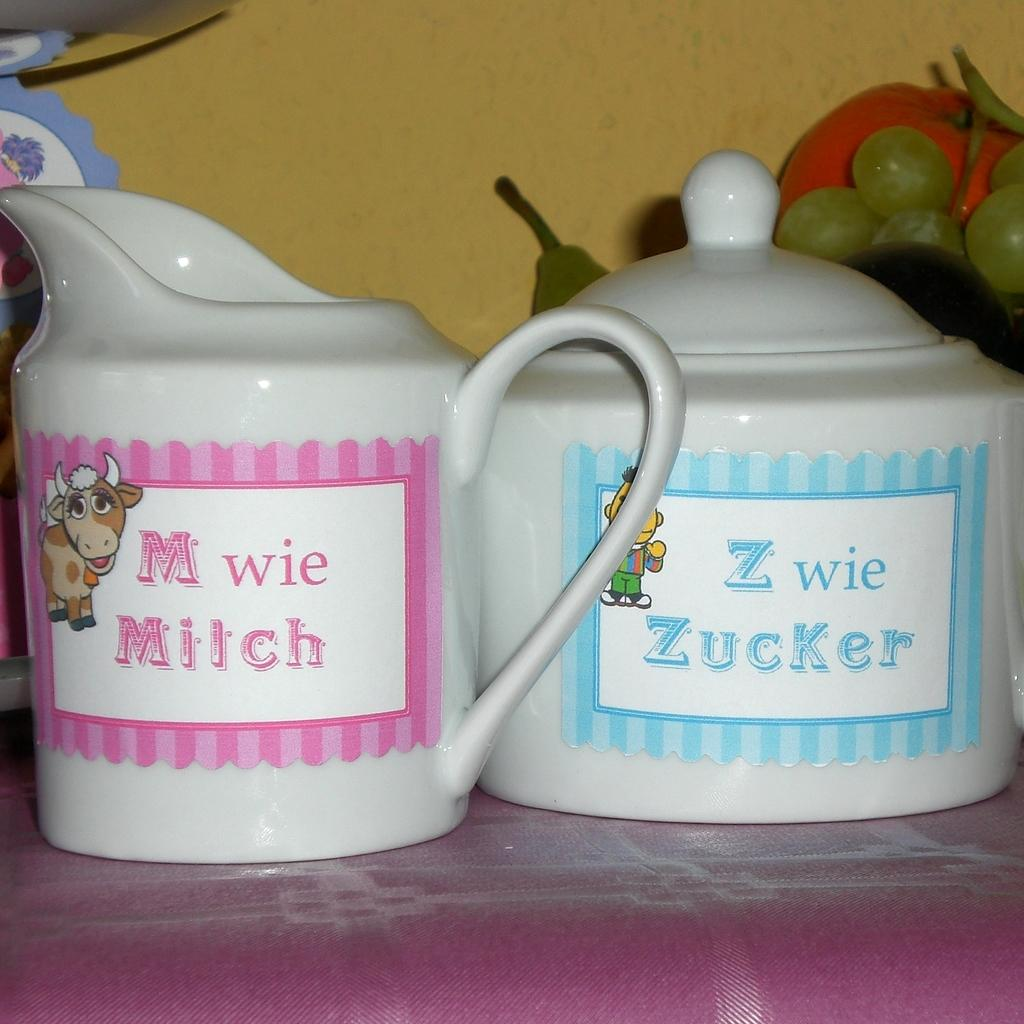How many glass vessels are visible in the image? There are two glass vessels in the image. What is located behind the second glass vessel? There are fruits behind the second glass vessel. What type of transport is visible in the image? There is no transport visible in the image. What is the weight of the flesh in the image? There is no flesh present in the image, so it cannot be weighed. 